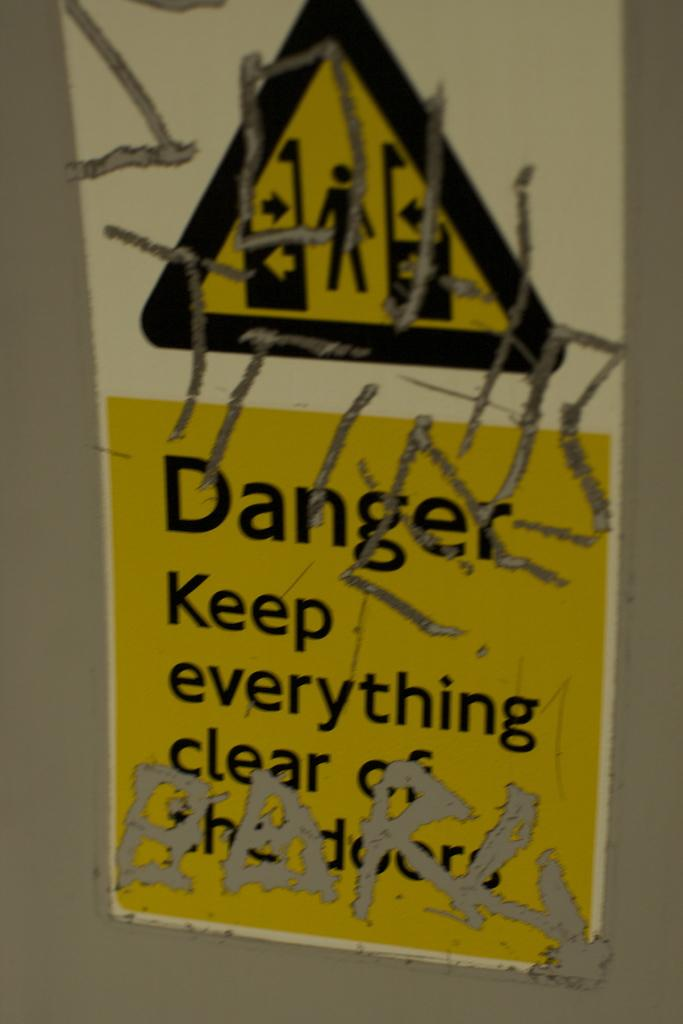What is on the wall in the image? There is a poster on the wall in the image. What is depicted on the poster? The poster contains a symbol of a person and arrows. Are there any words on the poster? Yes, there is text written on the poster. What type of plant is growing on the poster in the image? There is no plant depicted on the poster in the image; it contains a symbol of a person and arrows, along with text. Can you see a plane flying in the image? There is no plane visible in the image; it only features a poster on the wall. 